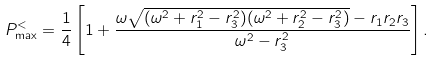Convert formula to latex. <formula><loc_0><loc_0><loc_500><loc_500>P _ { \max } ^ { < } = \frac { 1 } { 4 } \left [ 1 + \frac { \omega \sqrt { ( \omega ^ { 2 } + r _ { 1 } ^ { 2 } - r _ { 3 } ^ { 2 } ) ( \omega ^ { 2 } + r _ { 2 } ^ { 2 } - r _ { 3 } ^ { 2 } ) } - r _ { 1 } r _ { 2 } r _ { 3 } } { \omega ^ { 2 } - r _ { 3 } ^ { 2 } } \right ] .</formula> 